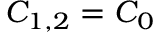<formula> <loc_0><loc_0><loc_500><loc_500>C _ { 1 , 2 } = C _ { 0 }</formula> 